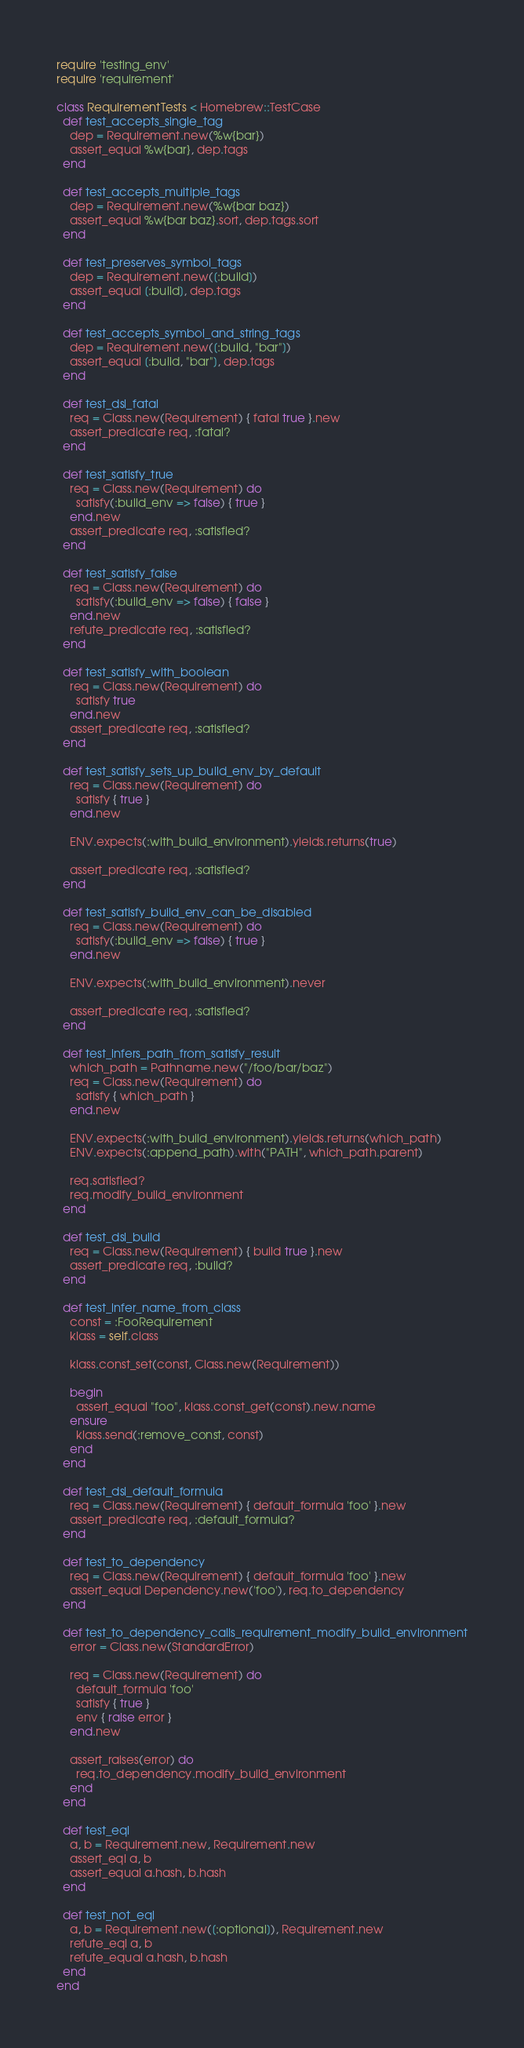Convert code to text. <code><loc_0><loc_0><loc_500><loc_500><_Ruby_>require 'testing_env'
require 'requirement'

class RequirementTests < Homebrew::TestCase
  def test_accepts_single_tag
    dep = Requirement.new(%w{bar})
    assert_equal %w{bar}, dep.tags
  end

  def test_accepts_multiple_tags
    dep = Requirement.new(%w{bar baz})
    assert_equal %w{bar baz}.sort, dep.tags.sort
  end

  def test_preserves_symbol_tags
    dep = Requirement.new([:build])
    assert_equal [:build], dep.tags
  end

  def test_accepts_symbol_and_string_tags
    dep = Requirement.new([:build, "bar"])
    assert_equal [:build, "bar"], dep.tags
  end

  def test_dsl_fatal
    req = Class.new(Requirement) { fatal true }.new
    assert_predicate req, :fatal?
  end

  def test_satisfy_true
    req = Class.new(Requirement) do
      satisfy(:build_env => false) { true }
    end.new
    assert_predicate req, :satisfied?
  end

  def test_satisfy_false
    req = Class.new(Requirement) do
      satisfy(:build_env => false) { false }
    end.new
    refute_predicate req, :satisfied?
  end

  def test_satisfy_with_boolean
    req = Class.new(Requirement) do
      satisfy true
    end.new
    assert_predicate req, :satisfied?
  end

  def test_satisfy_sets_up_build_env_by_default
    req = Class.new(Requirement) do
      satisfy { true }
    end.new

    ENV.expects(:with_build_environment).yields.returns(true)

    assert_predicate req, :satisfied?
  end

  def test_satisfy_build_env_can_be_disabled
    req = Class.new(Requirement) do
      satisfy(:build_env => false) { true }
    end.new

    ENV.expects(:with_build_environment).never

    assert_predicate req, :satisfied?
  end

  def test_infers_path_from_satisfy_result
    which_path = Pathname.new("/foo/bar/baz")
    req = Class.new(Requirement) do
      satisfy { which_path }
    end.new

    ENV.expects(:with_build_environment).yields.returns(which_path)
    ENV.expects(:append_path).with("PATH", which_path.parent)

    req.satisfied?
    req.modify_build_environment
  end

  def test_dsl_build
    req = Class.new(Requirement) { build true }.new
    assert_predicate req, :build?
  end

  def test_infer_name_from_class
    const = :FooRequirement
    klass = self.class

    klass.const_set(const, Class.new(Requirement))

    begin
      assert_equal "foo", klass.const_get(const).new.name
    ensure
      klass.send(:remove_const, const)
    end
  end

  def test_dsl_default_formula
    req = Class.new(Requirement) { default_formula 'foo' }.new
    assert_predicate req, :default_formula?
  end

  def test_to_dependency
    req = Class.new(Requirement) { default_formula 'foo' }.new
    assert_equal Dependency.new('foo'), req.to_dependency
  end

  def test_to_dependency_calls_requirement_modify_build_environment
    error = Class.new(StandardError)

    req = Class.new(Requirement) do
      default_formula 'foo'
      satisfy { true }
      env { raise error }
    end.new

    assert_raises(error) do
      req.to_dependency.modify_build_environment
    end
  end

  def test_eql
    a, b = Requirement.new, Requirement.new
    assert_eql a, b
    assert_equal a.hash, b.hash
  end

  def test_not_eql
    a, b = Requirement.new([:optional]), Requirement.new
    refute_eql a, b
    refute_equal a.hash, b.hash
  end
end
</code> 